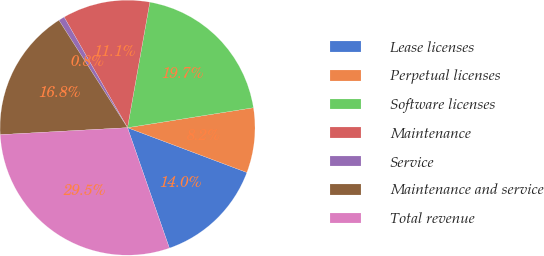Convert chart. <chart><loc_0><loc_0><loc_500><loc_500><pie_chart><fcel>Lease licenses<fcel>Perpetual licenses<fcel>Software licenses<fcel>Maintenance<fcel>Service<fcel>Maintenance and service<fcel>Total revenue<nl><fcel>13.96%<fcel>8.22%<fcel>19.7%<fcel>11.09%<fcel>0.76%<fcel>16.83%<fcel>29.46%<nl></chart> 